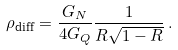<formula> <loc_0><loc_0><loc_500><loc_500>\rho _ { \text {diff} } = \frac { G _ { N } } { 4 G _ { Q } } \frac { 1 } { R \sqrt { 1 - R } } \, .</formula> 